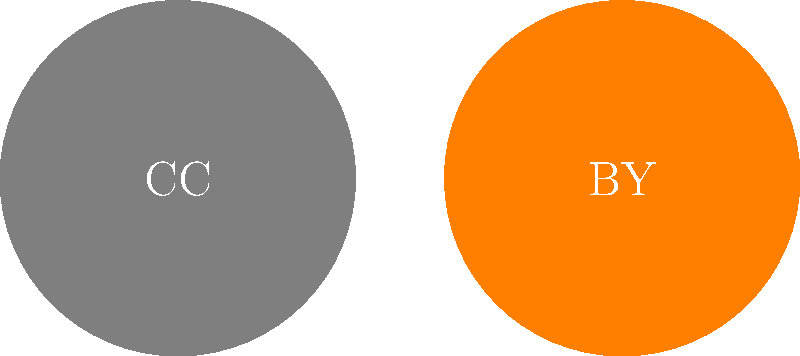In the chart above, which number corresponds to the Creative Commons license symbol that allows for commercial use of the work? To answer this question, we need to understand the meaning of each Creative Commons license symbol:

1. CC (Creative Commons): The base symbol for all Creative Commons licenses.
2. BY (Attribution): Requires giving credit to the original creator.
3. SA (Share Alike): Requires derivative works to be shared under the same license.
4. NC (Non-Commercial): Prohibits commercial use of the work.
5. ND (No Derivatives): Prohibits creating derivative works.

The question asks for the symbol that allows for commercial use. To determine this, we need to identify which symbol, when absent, would restrict commercial use.

The NC (Non-Commercial) symbol, when present, explicitly prohibits commercial use. Therefore, its absence implies that commercial use is allowed.

In the chart, the NC symbol is labeled with the number 4.

Since we're looking for the symbol that allows commercial use, we need to choose any number except 4. The most appropriate choice would be 2 (BY - Attribution), as it's the most basic license that allows for commercial use while still requiring attribution.
Answer: 2 